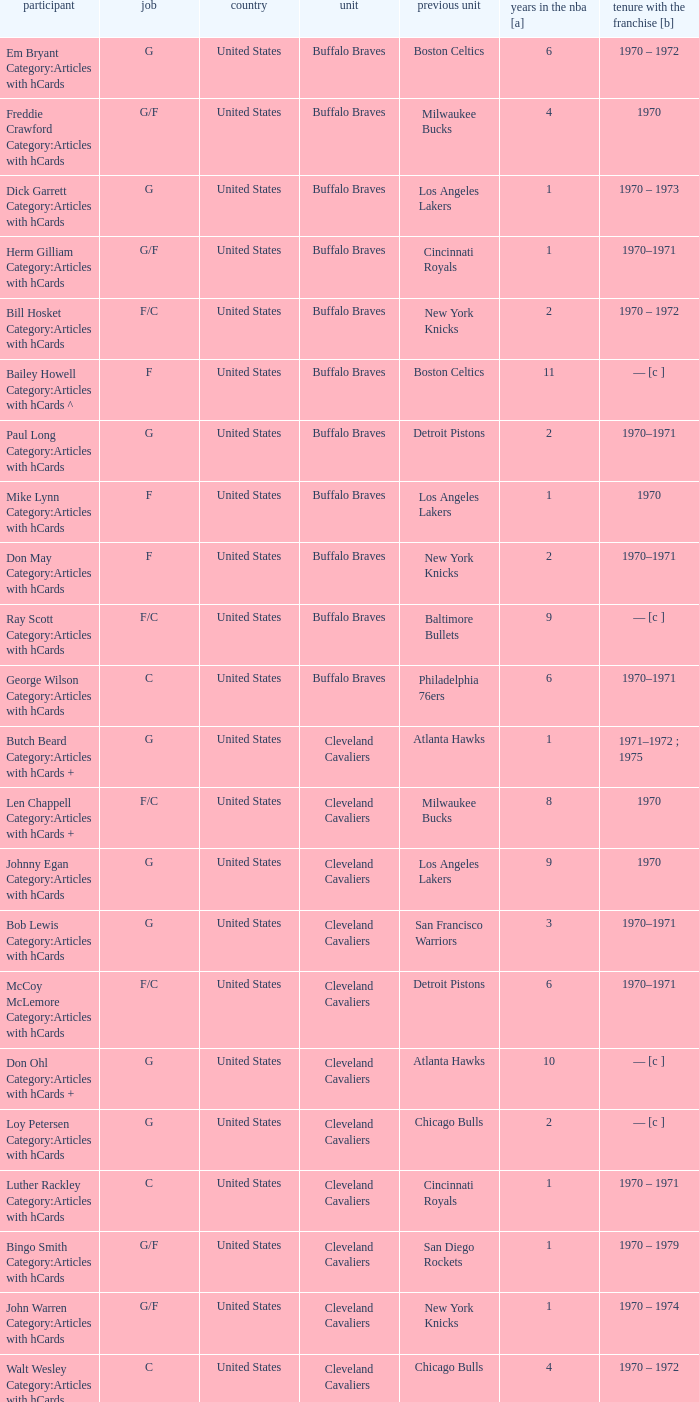How many years of NBA experience does the player who plays position g for the Portland Trail Blazers? 2.0. 